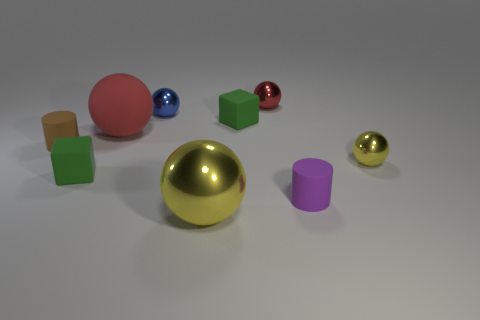Can you describe the lighting and shadows in the scene? The lighting in the image is soft and diffused, coming from the upper right. Shadows are cast to the lower left of the objects, indicating the direction of the light source. The shadows are soft-edged, suggesting that the light source is not overly harsh or direct. 